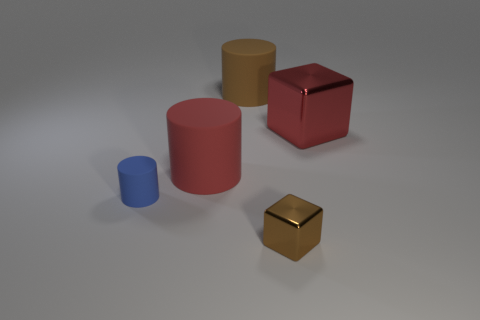Which objects in the image are taller than the red matte cube? The red cylindrical object is taller than the red matte cube. The other objects are either shorter or of different shapes. 